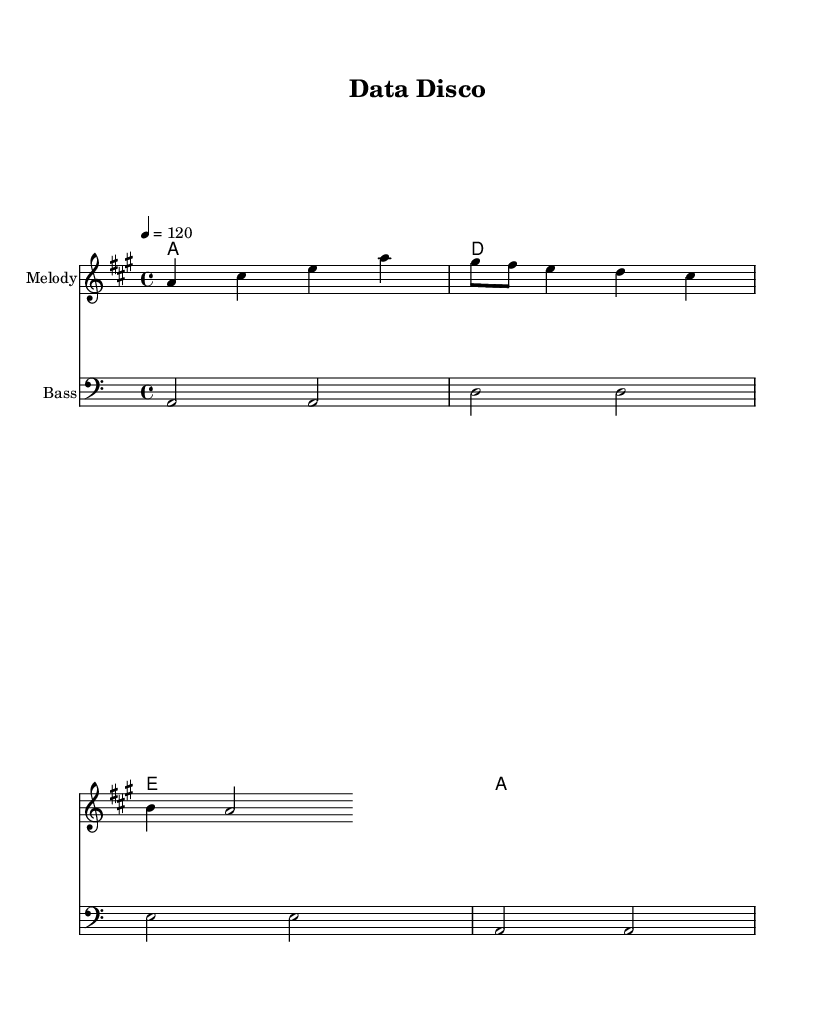What is the tempo of this music? The tempo is indicated as "4 = 120," which means there are 120 beats per minute.
Answer: 120 What is the time signature of this sheet music? The time signature shown is 4/4, which indicates there are four beats in each measure and that a quarter note gets one beat.
Answer: 4/4 How many measures are in the melody section? The melody consists of three measures, as seen in the grouping of notes.
Answer: 3 What is the main theme of the lyrics? The lyrics focus on organizing code and data structures, as indicated by the phrases "organize your code" and "data structures."
Answer: Organizing code What is the key signature of this music? The key signature is A major, which is identified by three sharps (F#, C#, G#) shown in the key signature section at the beginning of the piece.
Answer: A major Which voices are present in the score? The score contains a melody, a bass line, and chord names that specify harmonies, representing both the musical accompaniment and the main melody.
Answer: Melody, Bass 